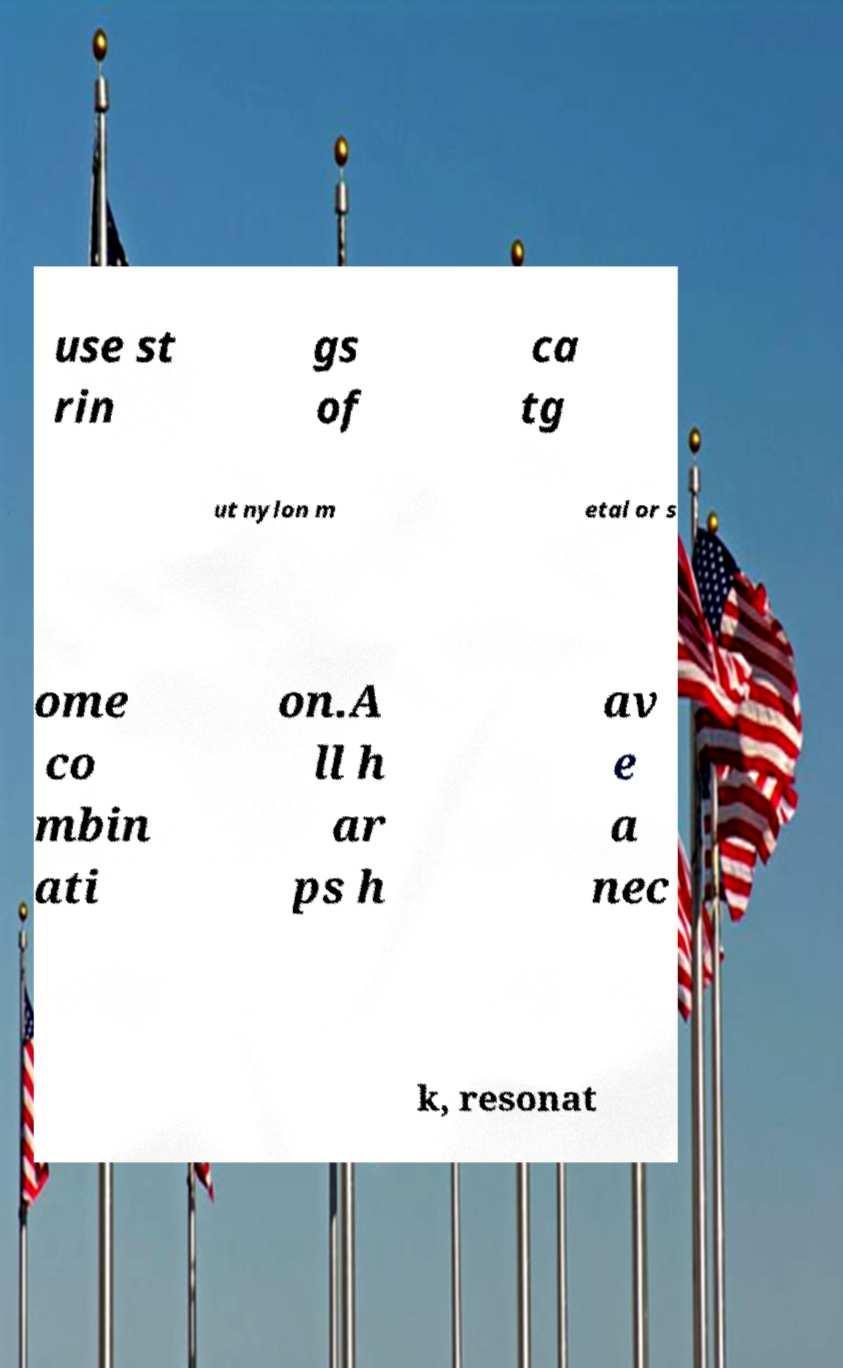There's text embedded in this image that I need extracted. Can you transcribe it verbatim? use st rin gs of ca tg ut nylon m etal or s ome co mbin ati on.A ll h ar ps h av e a nec k, resonat 